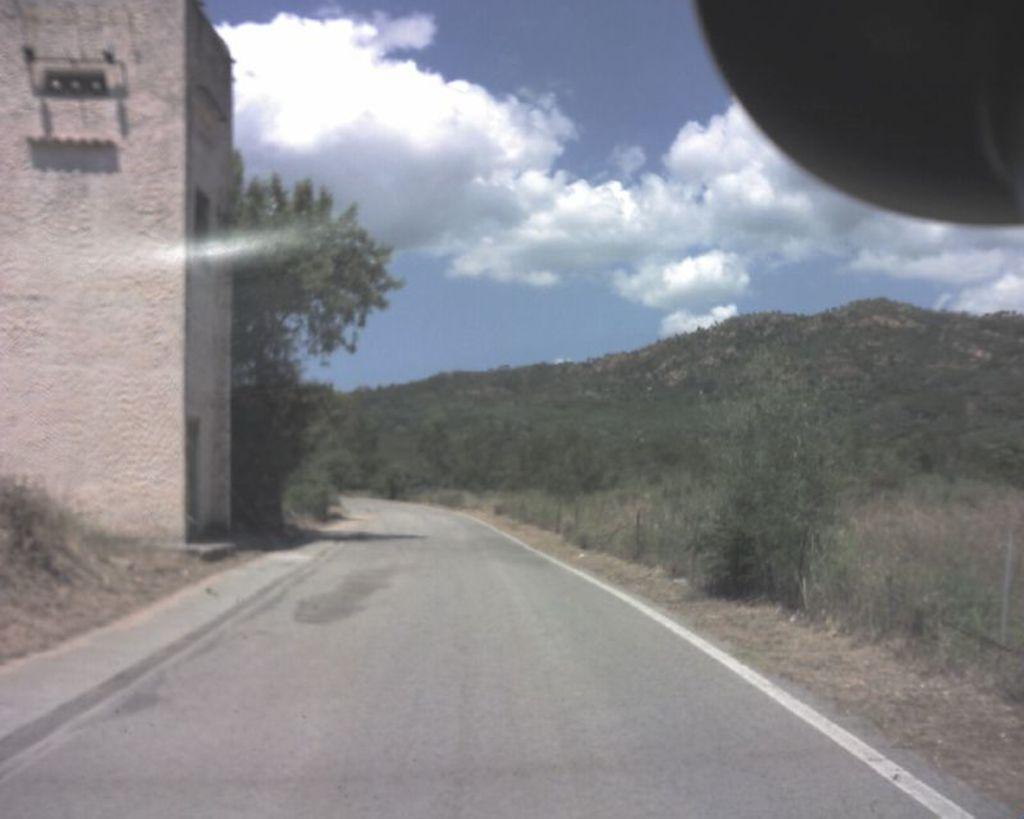Please provide a concise description of this image. In this picture we can see the road. On the left side there is a building wall and some trees. On the right there is a small mountain full of trees. On the top there is a sky and clouds. 